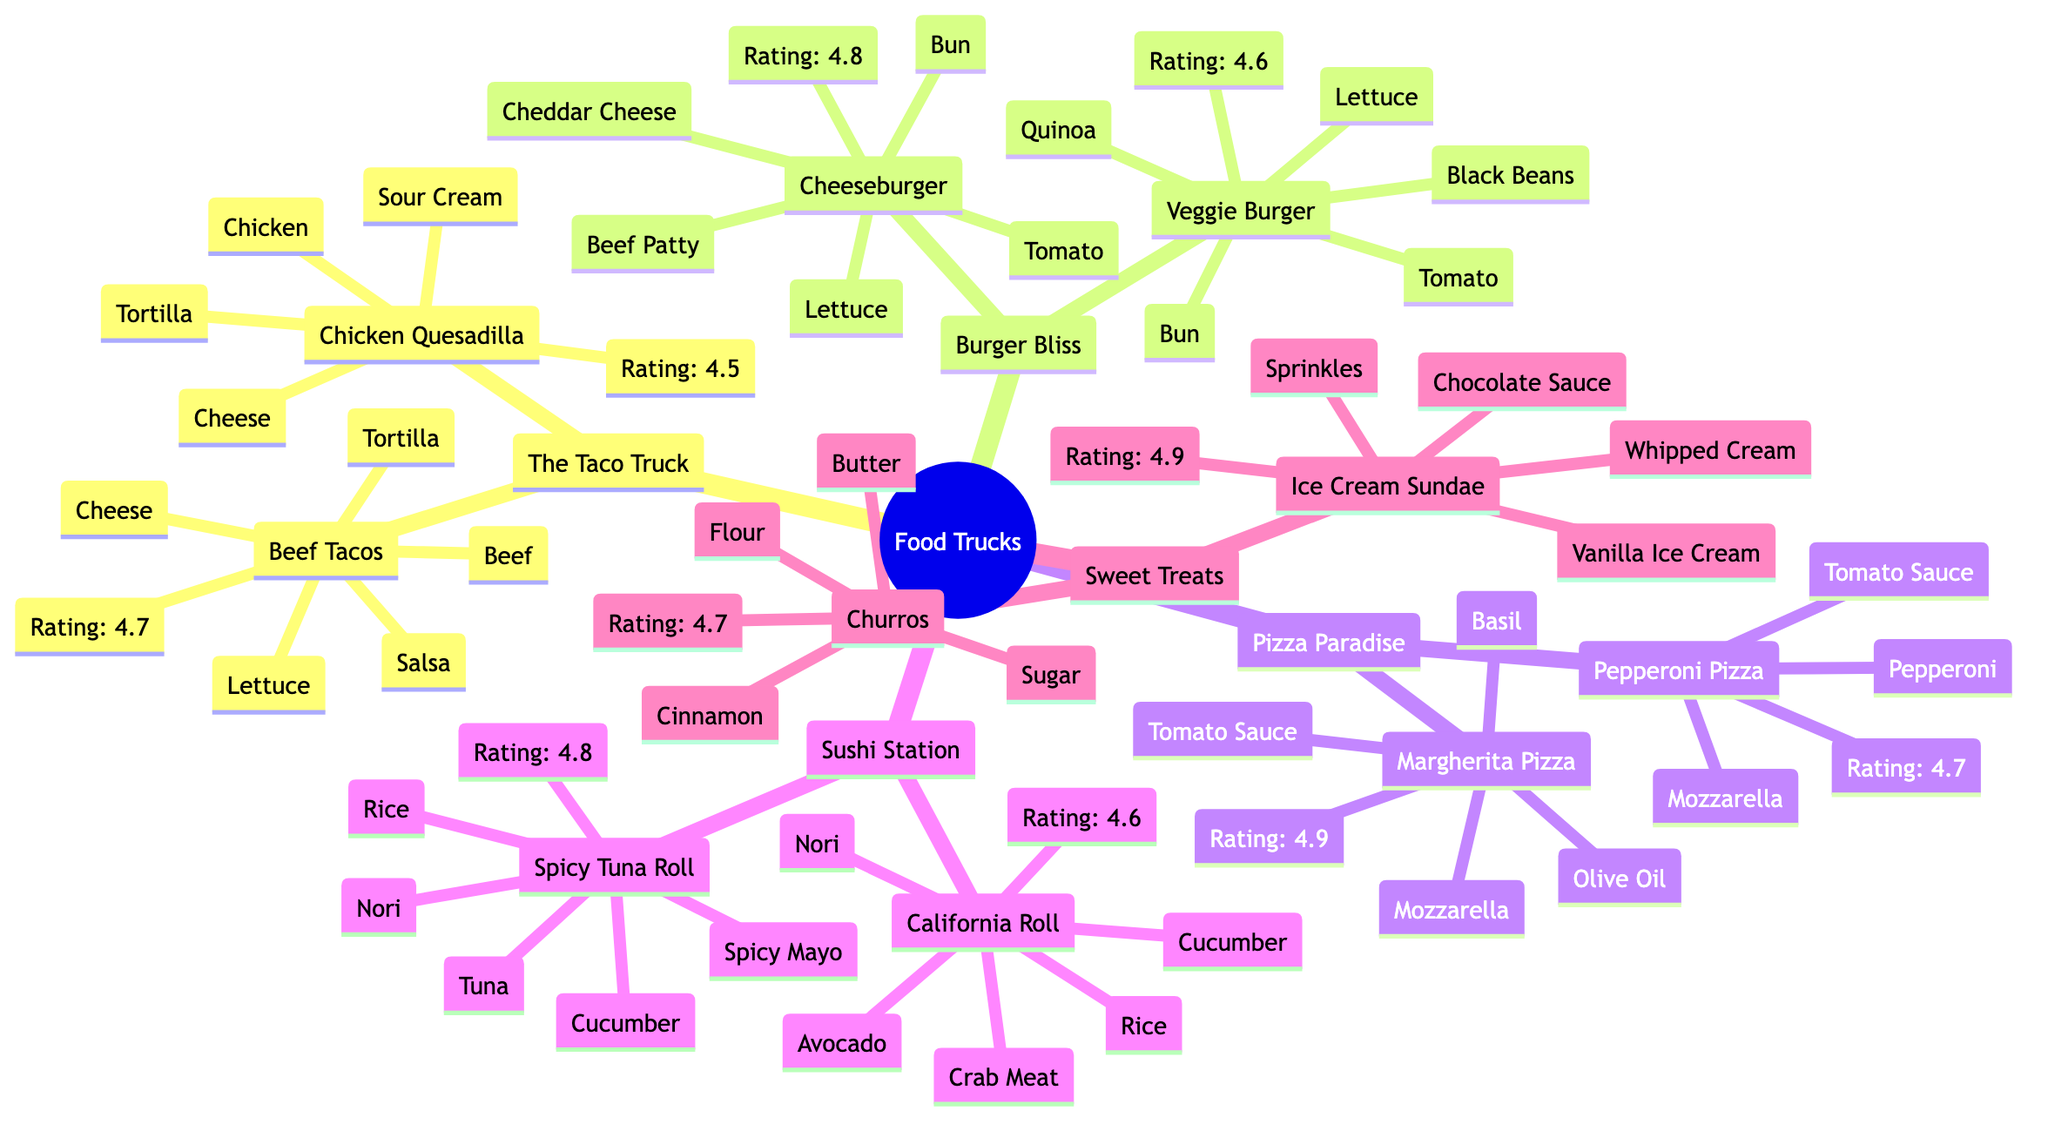What is the rating of Beef Tacos? The diagram shows that the rating of Beef Tacos, which is found under The Taco Truck, is 4.7.
Answer: 4.7 How many dishes does Pizza Paradise offer? Pizza Paradise has two dishes listed: Margherita Pizza and Pepperoni Pizza, so the total number is two.
Answer: 2 What ingredients are in the Ice Cream Sundae? The ingredients listed for Ice Cream Sundae are Vanilla Ice Cream, Chocolate Sauce, Sprinkles, and Whipped Cream.
Answer: Vanilla Ice Cream, Chocolate Sauce, Sprinkles, Whipped Cream Which food truck has the highest-rated dish? Inspecting the ratings, the highest-rated dish is Margherita Pizza from Pizza Paradise with a rating of 4.9.
Answer: Margherita Pizza What is the relationship between Sweet Treats and its dishes? Sweet Treats is a food truck, and it has two associated dishes: Churros and Ice Cream Sundae, showing a parent-child relationship.
Answer: Sweet Treats and its dishes are Churros, Ice Cream Sundae Which dish has a rating of 4.6 and is offered by Burger Bliss? The Veggie Burger is the dish with a rating of 4.6 that is offered by the food truck Burger Bliss.
Answer: Veggie Burger How many food trucks serve dishes containing cheese? By analyzing the dishes, The Taco Truck, Burger Bliss, and Pizza Paradise all serve dishes with cheese, totaling three food trucks.
Answer: 3 What ingredients are common between all dishes at Sushi Station? Looking at the dishes under Sushi Station, the two dishes, California Roll and Spicy Tuna Roll, both contain Rice and Nori, making them the common ingredients.
Answer: Rice, Nori What is the average rating of dishes offered by Sweet Treats? The average rating can be calculated by adding the ratings of Churros (4.7) and Ice Cream Sundae (4.9), which totals 9.6, and then dividing by 2, resulting in an average rating of 4.8.
Answer: 4.8 